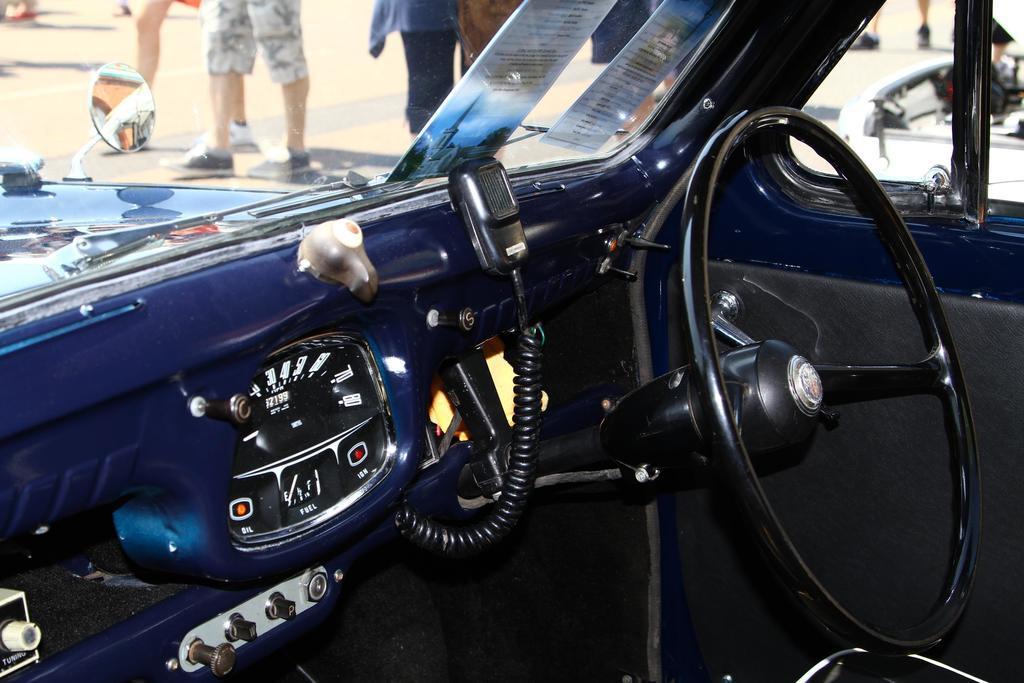Could you give a brief overview of what you see in this image? In the image we can see an internal structure of the vehicle. This is a steering and these are the windows of the vehicle. Out of the window we can see there are people standing, they are wearing clothes and shoes, this is a road. 